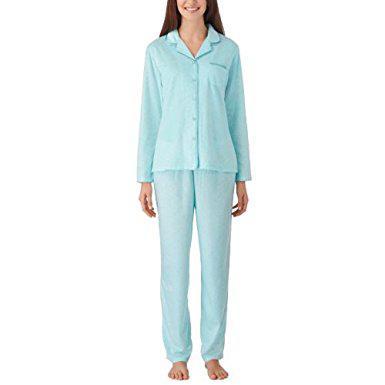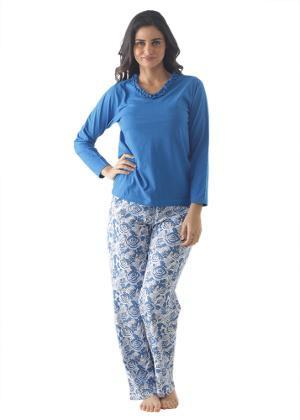The first image is the image on the left, the second image is the image on the right. Examine the images to the left and right. Is the description "Both models are wearing the same design of pajamas." accurate? Answer yes or no. No. The first image is the image on the left, the second image is the image on the right. For the images shown, is this caption "Each model wears printed pajamas, and each pajama outfit includes a button-up top with a shirt collar." true? Answer yes or no. No. 